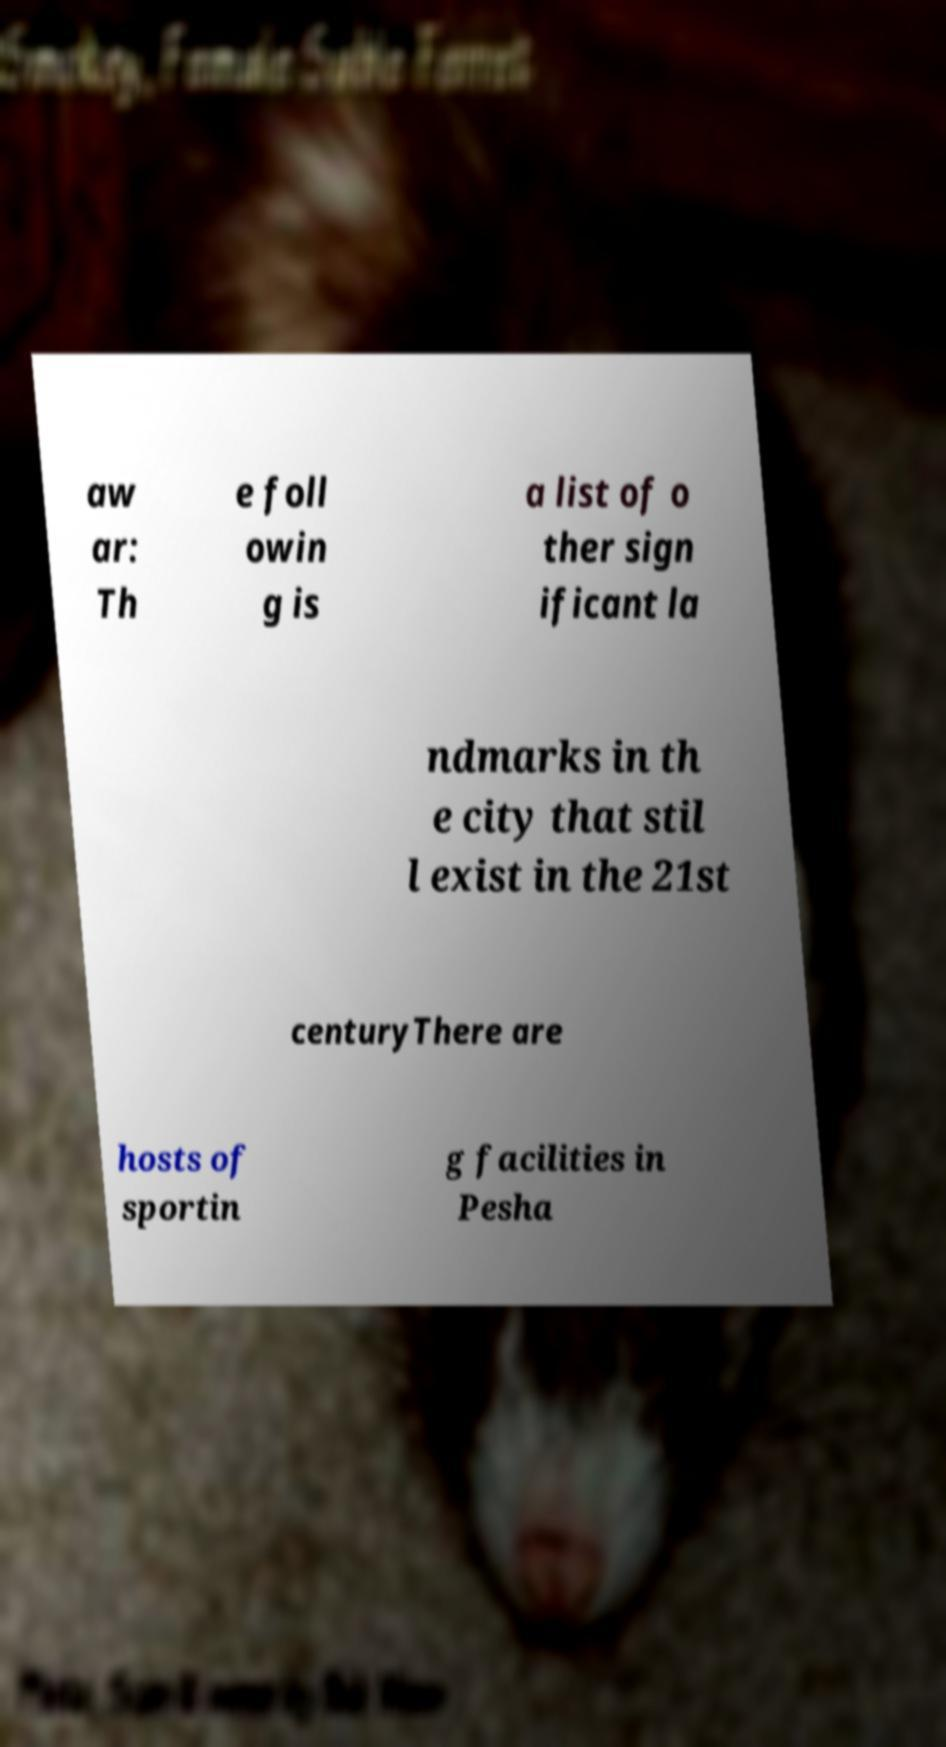Could you extract and type out the text from this image? aw ar: Th e foll owin g is a list of o ther sign ificant la ndmarks in th e city that stil l exist in the 21st centuryThere are hosts of sportin g facilities in Pesha 